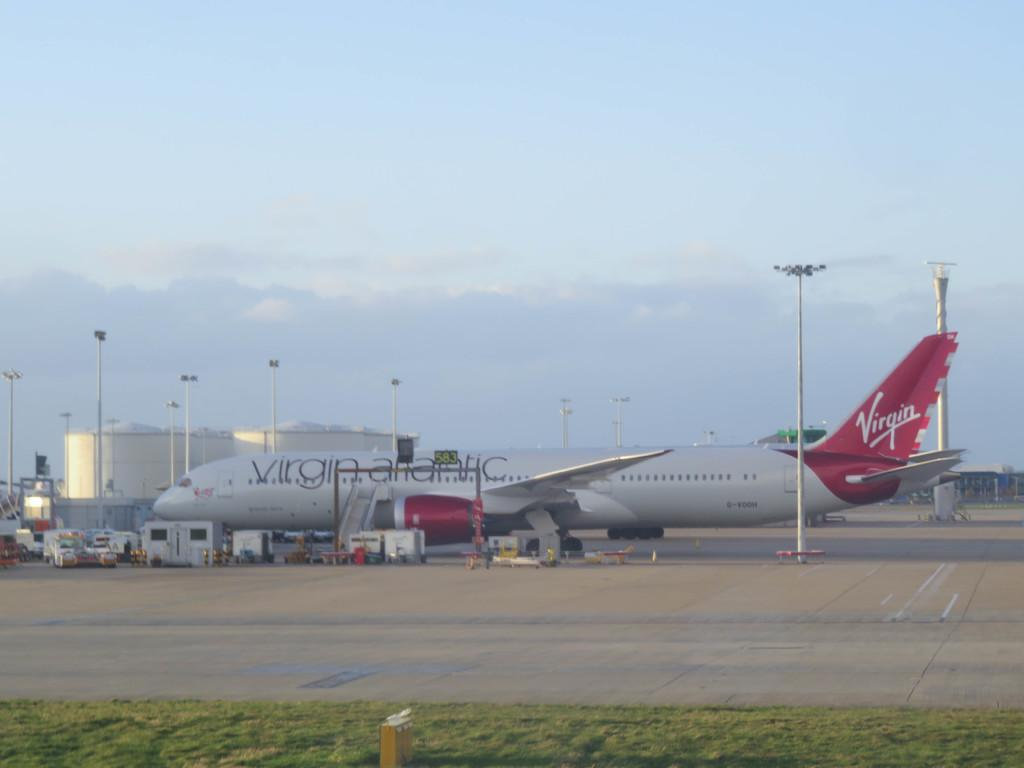Provide a one-sentence caption for the provided image. a virgin airlines plane is being loaded at the airport. 